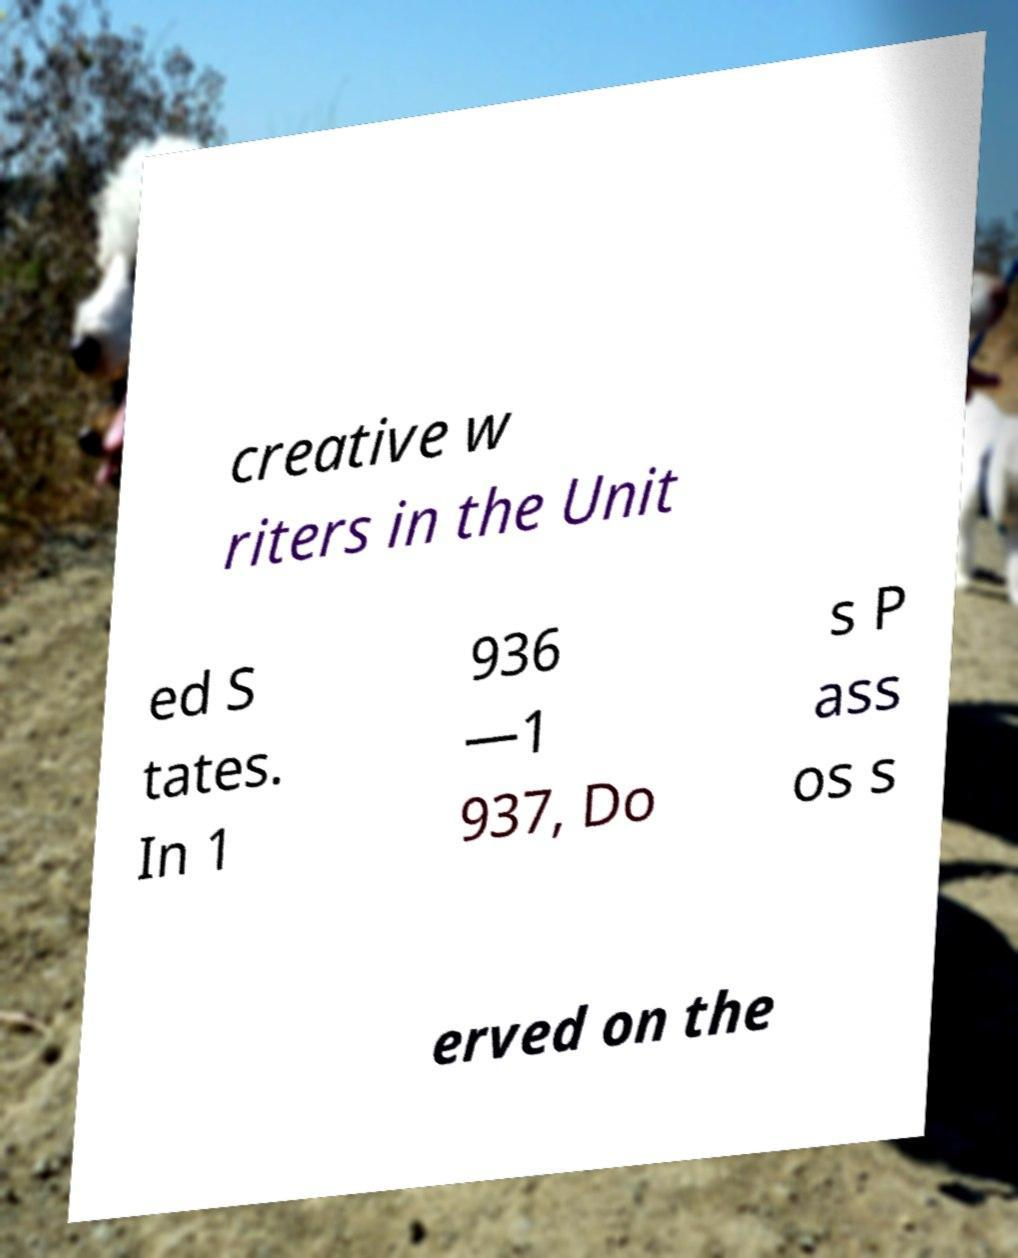What messages or text are displayed in this image? I need them in a readable, typed format. creative w riters in the Unit ed S tates. In 1 936 —1 937, Do s P ass os s erved on the 